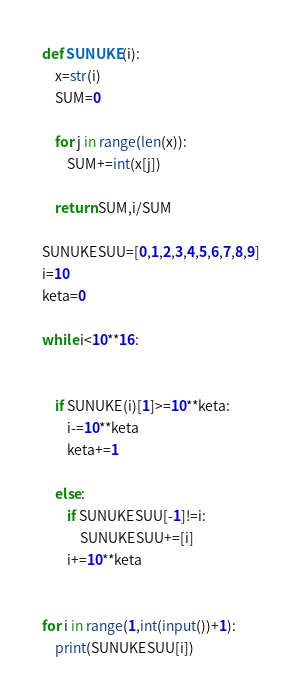Convert code to text. <code><loc_0><loc_0><loc_500><loc_500><_Python_>def SUNUKE(i):
    x=str(i)
    SUM=0

    for j in range(len(x)):
        SUM+=int(x[j])

    return SUM,i/SUM

SUNUKESUU=[0,1,2,3,4,5,6,7,8,9]
i=10
keta=0

while i<10**16:


    if SUNUKE(i)[1]>=10**keta:
        i-=10**keta
        keta+=1
        
    else:
        if SUNUKESUU[-1]!=i:
            SUNUKESUU+=[i]
        i+=10**keta
    

for i in range(1,int(input())+1):
    print(SUNUKESUU[i])</code> 